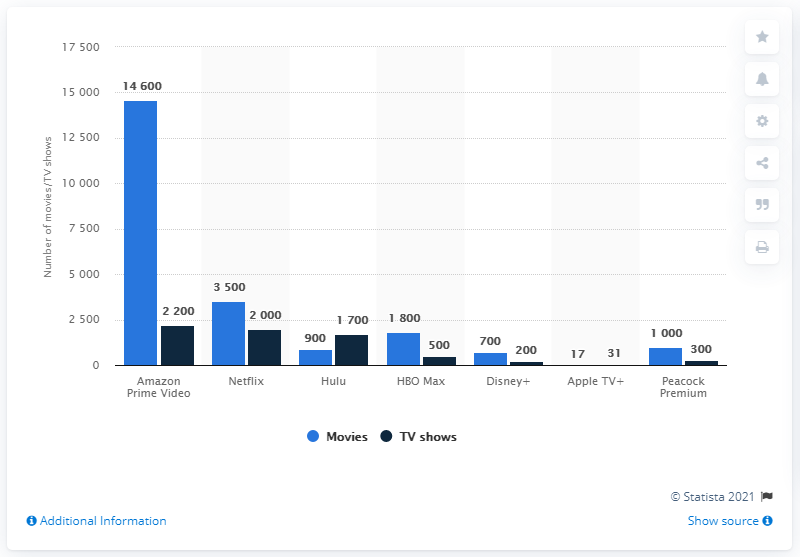Point out several critical features in this image. As of the time of our records, a total of 17 movies were available on Apple TV+. Amazon Prime Video had the largest content catalog of movies and TV shows in the US, consisting of numerous titles that catered to a wide range of interests and preferences. 